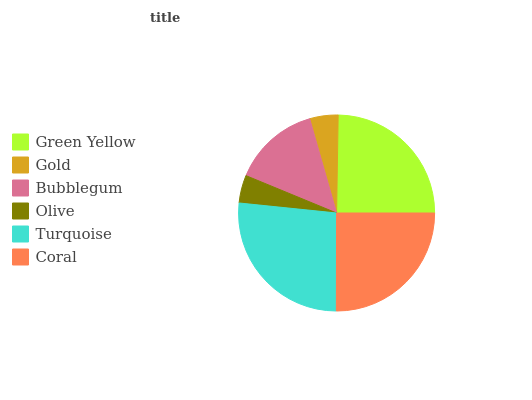Is Olive the minimum?
Answer yes or no. Yes. Is Turquoise the maximum?
Answer yes or no. Yes. Is Gold the minimum?
Answer yes or no. No. Is Gold the maximum?
Answer yes or no. No. Is Green Yellow greater than Gold?
Answer yes or no. Yes. Is Gold less than Green Yellow?
Answer yes or no. Yes. Is Gold greater than Green Yellow?
Answer yes or no. No. Is Green Yellow less than Gold?
Answer yes or no. No. Is Green Yellow the high median?
Answer yes or no. Yes. Is Bubblegum the low median?
Answer yes or no. Yes. Is Gold the high median?
Answer yes or no. No. Is Turquoise the low median?
Answer yes or no. No. 